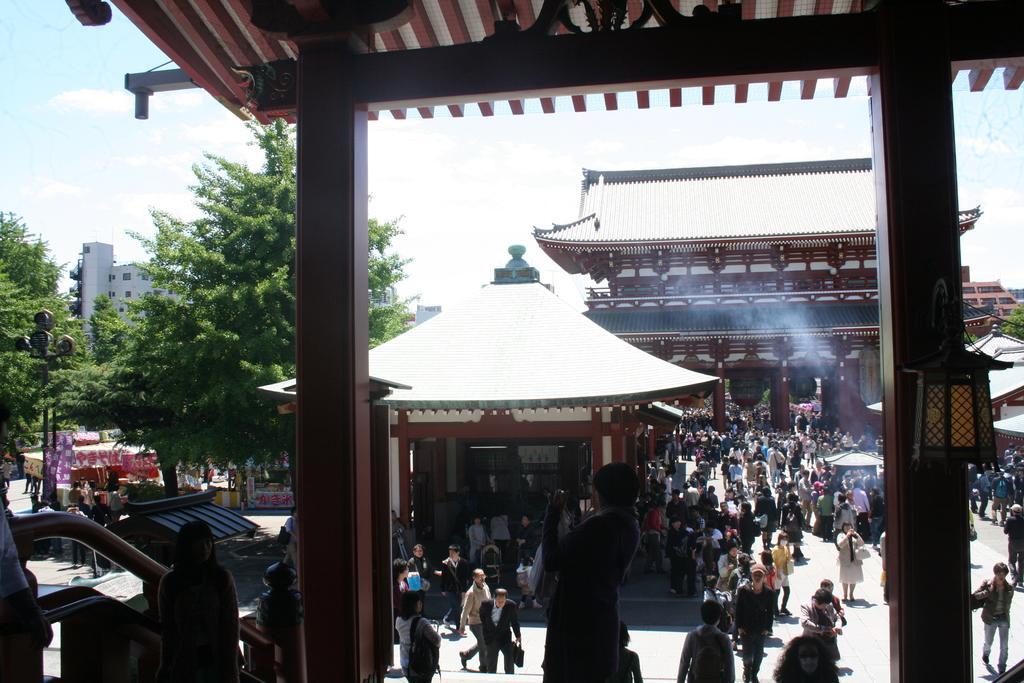Describe this image in one or two sentences. This is shed. Here we can see trees, buildings, light pole, people, store, buildings and stalls. Background there is a sky. Sky is cloudy. Lamp is attached to this wooden pillar. 